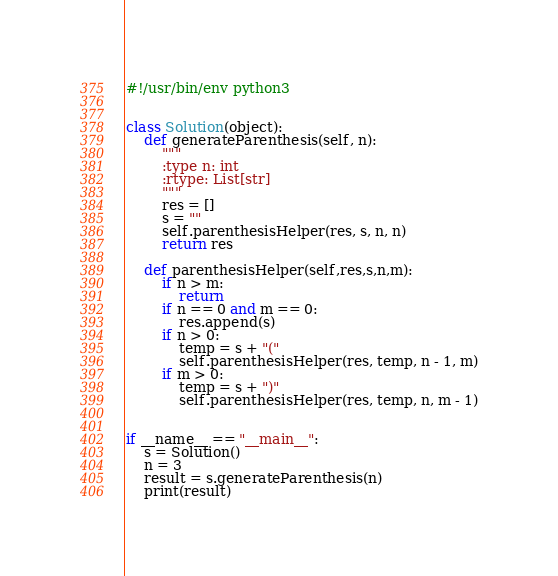<code> <loc_0><loc_0><loc_500><loc_500><_Python_>#!/usr/bin/env python3


class Solution(object):
    def generateParenthesis(self, n):
        """
        :type n: int
        :rtype: List[str]
        """
        res = []
        s = ""
        self.parenthesisHelper(res, s, n, n)
        return res

    def parenthesisHelper(self,res,s,n,m):
        if n > m:
            return
        if n == 0 and m == 0:
            res.append(s)
        if n > 0:
            temp = s + "("
            self.parenthesisHelper(res, temp, n - 1, m)
        if m > 0:
            temp = s + ")"
            self.parenthesisHelper(res, temp, n, m - 1)


if __name__ == "__main__":
    s = Solution()
    n = 3
    result = s.generateParenthesis(n)
    print(result)
</code> 